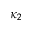Convert formula to latex. <formula><loc_0><loc_0><loc_500><loc_500>\kappa _ { 2 }</formula> 